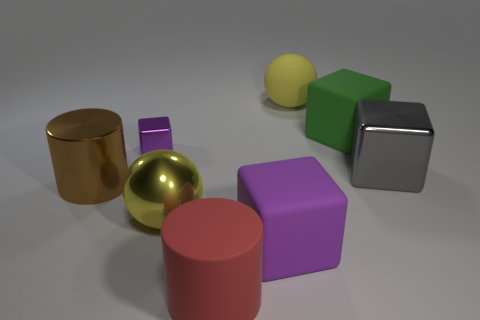Add 1 large blue shiny cylinders. How many objects exist? 9 Subtract all big purple rubber blocks. How many blocks are left? 3 Subtract all purple blocks. How many blocks are left? 2 Subtract 0 blue cubes. How many objects are left? 8 Subtract all spheres. How many objects are left? 6 Subtract 2 blocks. How many blocks are left? 2 Subtract all blue cubes. Subtract all cyan balls. How many cubes are left? 4 Subtract all red cylinders. How many gray cubes are left? 1 Subtract all tiny yellow cubes. Subtract all big green blocks. How many objects are left? 7 Add 1 red rubber cylinders. How many red rubber cylinders are left? 2 